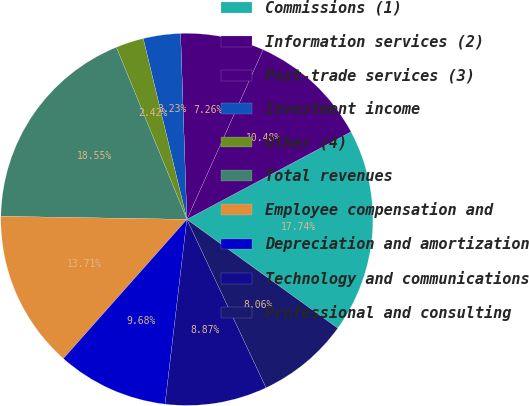Convert chart to OTSL. <chart><loc_0><loc_0><loc_500><loc_500><pie_chart><fcel>Commissions (1)<fcel>Information services (2)<fcel>Post-trade services (3)<fcel>Investment income<fcel>Other (4)<fcel>Total revenues<fcel>Employee compensation and<fcel>Depreciation and amortization<fcel>Technology and communications<fcel>Professional and consulting<nl><fcel>17.74%<fcel>10.48%<fcel>7.26%<fcel>3.23%<fcel>2.42%<fcel>18.55%<fcel>13.71%<fcel>9.68%<fcel>8.87%<fcel>8.06%<nl></chart> 